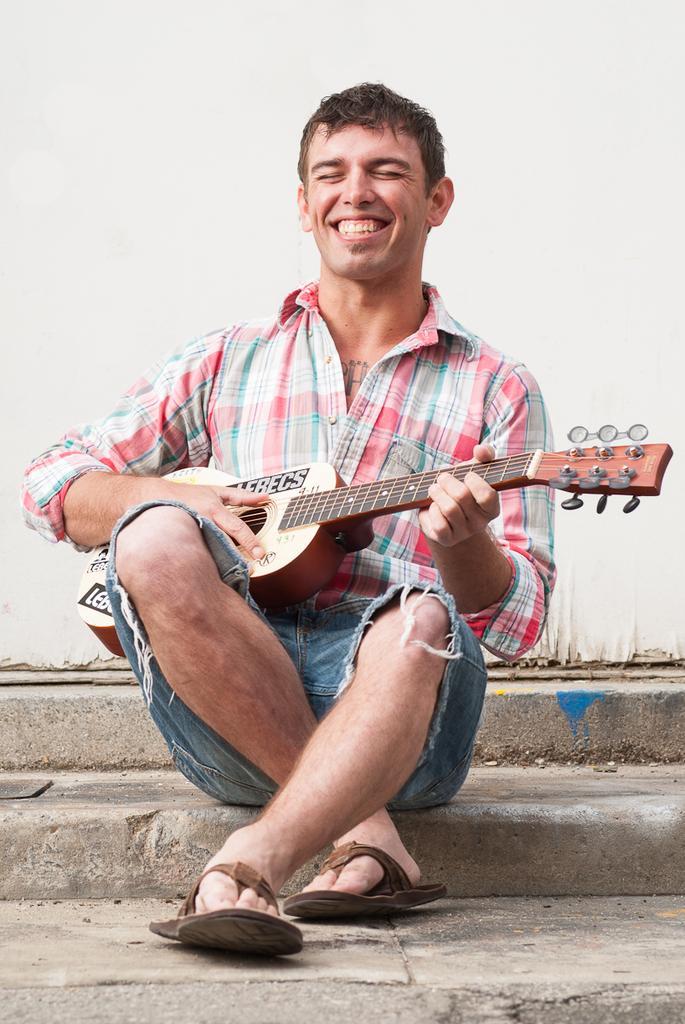In one or two sentences, can you explain what this image depicts? In this picture i could see a person holding a guitar in his hands and giving a smile, he is sitting on the steps and in the background there is a white colored wall. 